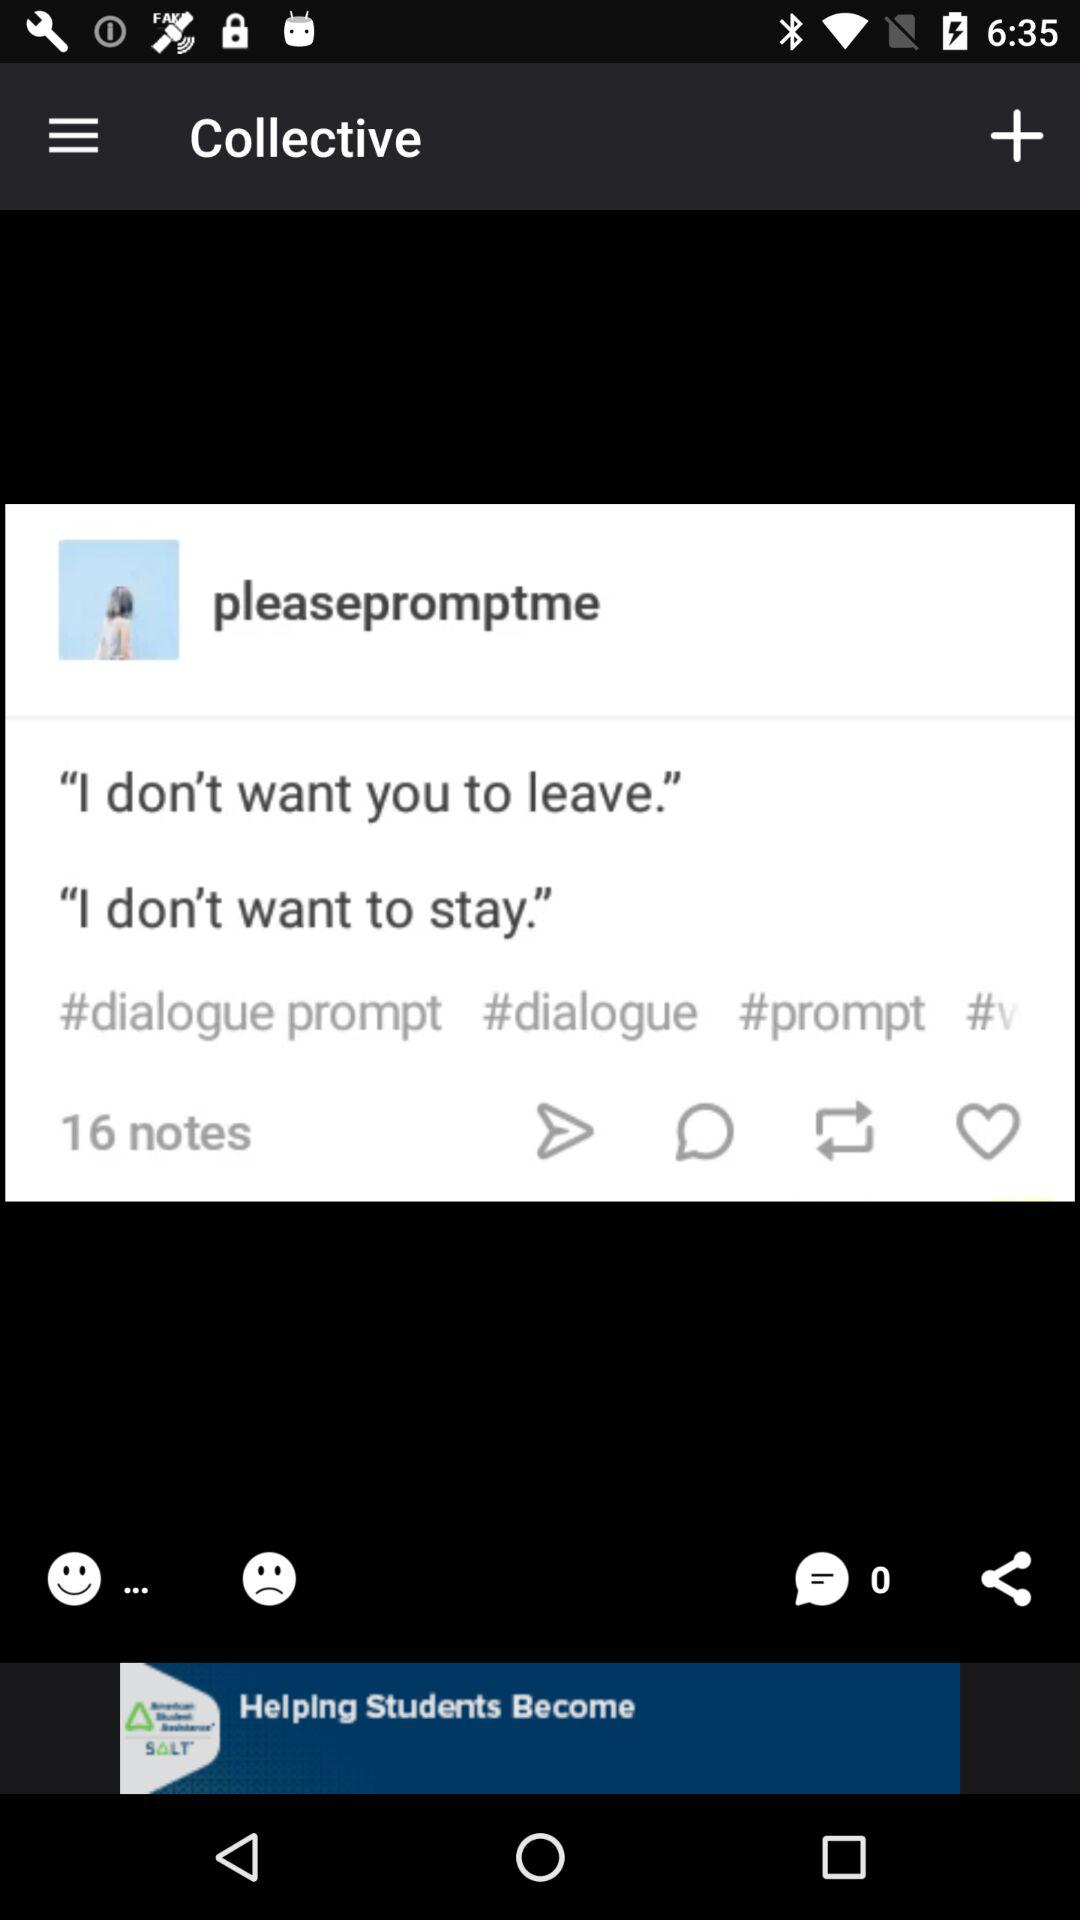How many notes are there?
Answer the question using a single word or phrase. 16 